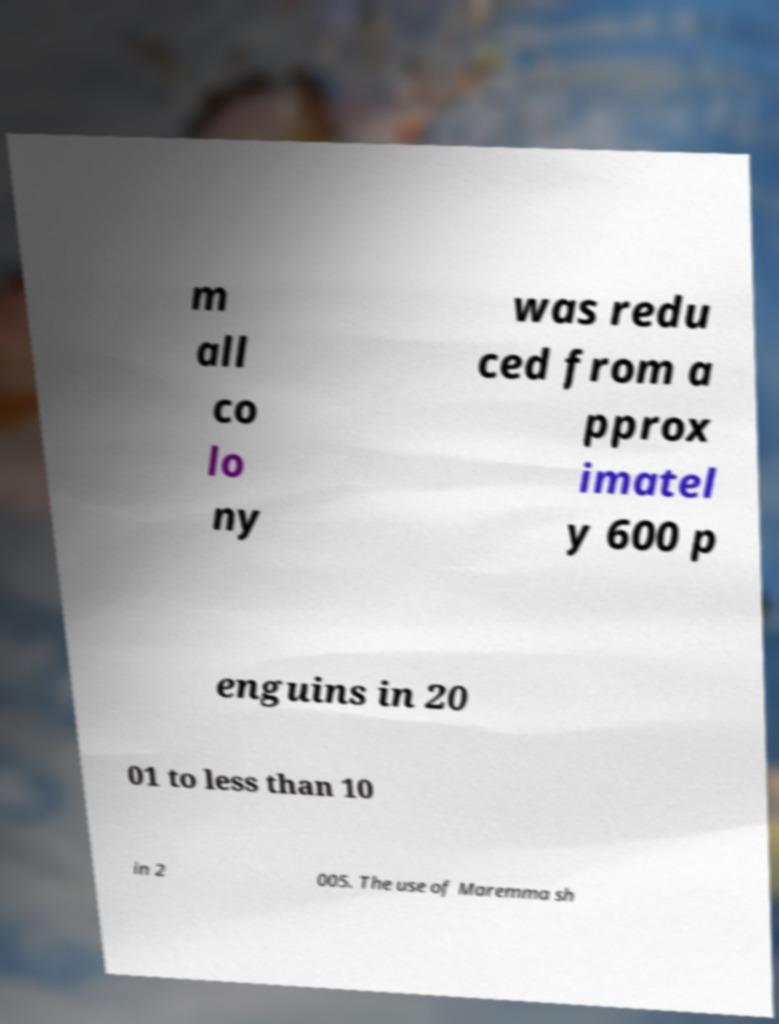I need the written content from this picture converted into text. Can you do that? m all co lo ny was redu ced from a pprox imatel y 600 p enguins in 20 01 to less than 10 in 2 005. The use of Maremma sh 